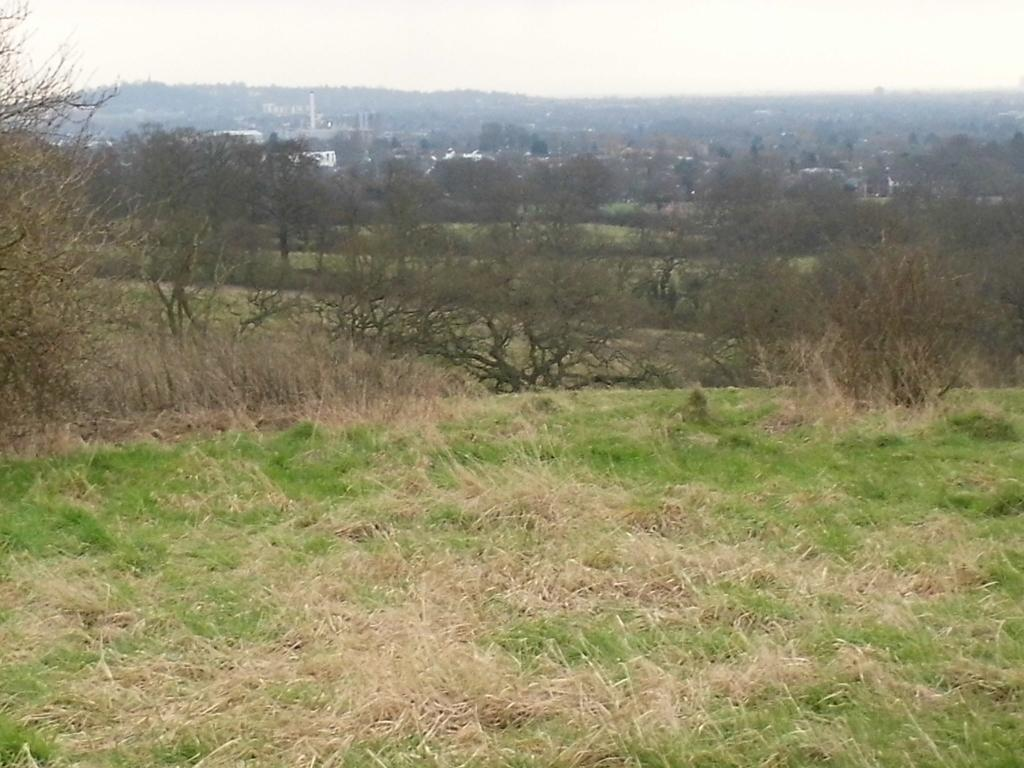What is located in the center of the image? There are trees in the center of the image. What type of vegetation is at the bottom of the image? There is grass at the bottom of the image. What can be seen in the background of the image? There are buildings, a hill, and the sky visible in the background of the image. What type of tax is being discussed in the image? There is no discussion of tax in the image; it features trees, grass, buildings, a hill, and the sky. Can you tell me what your dad is doing in the image? There is no person, including a dad, present in the image. 